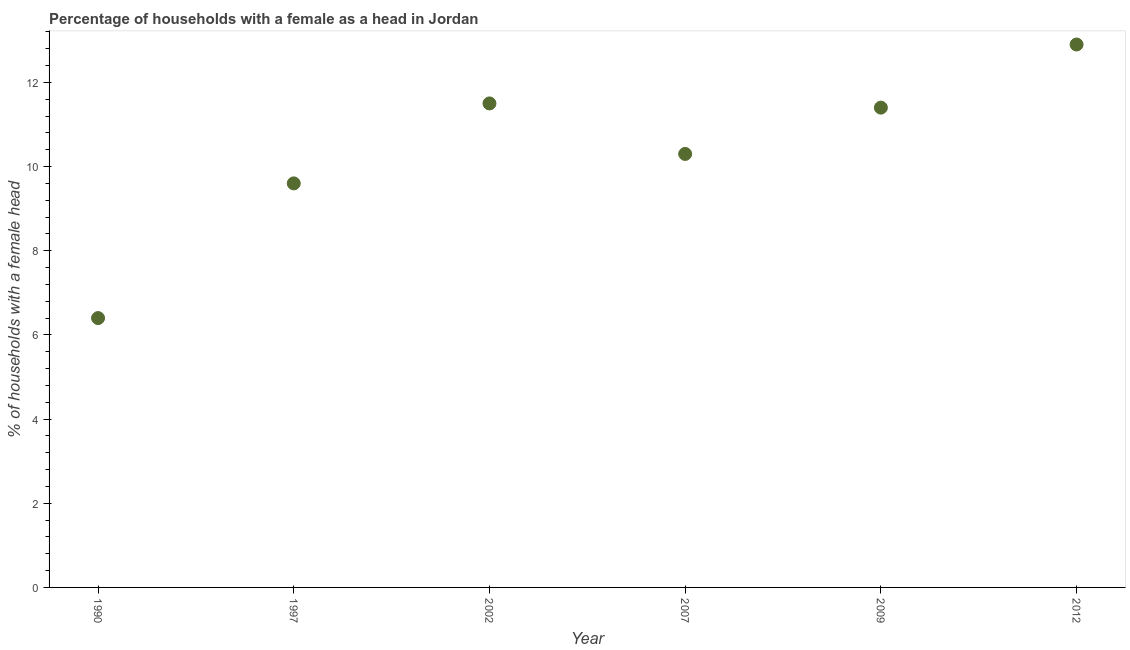What is the number of female supervised households in 2009?
Make the answer very short. 11.4. Across all years, what is the maximum number of female supervised households?
Ensure brevity in your answer.  12.9. What is the sum of the number of female supervised households?
Your answer should be compact. 62.1. What is the difference between the number of female supervised households in 1997 and 2009?
Offer a terse response. -1.8. What is the average number of female supervised households per year?
Provide a succinct answer. 10.35. What is the median number of female supervised households?
Make the answer very short. 10.85. In how many years, is the number of female supervised households greater than 7.2 %?
Give a very brief answer. 5. Do a majority of the years between 2007 and 1990 (inclusive) have number of female supervised households greater than 2 %?
Make the answer very short. Yes. What is the ratio of the number of female supervised households in 1997 to that in 2009?
Ensure brevity in your answer.  0.84. Is the difference between the number of female supervised households in 2002 and 2007 greater than the difference between any two years?
Provide a succinct answer. No. What is the difference between the highest and the second highest number of female supervised households?
Make the answer very short. 1.4. How many years are there in the graph?
Your answer should be compact. 6. Are the values on the major ticks of Y-axis written in scientific E-notation?
Your response must be concise. No. Does the graph contain any zero values?
Offer a very short reply. No. Does the graph contain grids?
Provide a short and direct response. No. What is the title of the graph?
Provide a succinct answer. Percentage of households with a female as a head in Jordan. What is the label or title of the X-axis?
Provide a short and direct response. Year. What is the label or title of the Y-axis?
Provide a succinct answer. % of households with a female head. What is the % of households with a female head in 1997?
Your answer should be compact. 9.6. What is the % of households with a female head in 2009?
Offer a terse response. 11.4. What is the difference between the % of households with a female head in 1990 and 2002?
Give a very brief answer. -5.1. What is the difference between the % of households with a female head in 1990 and 2009?
Ensure brevity in your answer.  -5. What is the difference between the % of households with a female head in 1990 and 2012?
Provide a succinct answer. -6.5. What is the difference between the % of households with a female head in 1997 and 2012?
Provide a succinct answer. -3.3. What is the ratio of the % of households with a female head in 1990 to that in 1997?
Give a very brief answer. 0.67. What is the ratio of the % of households with a female head in 1990 to that in 2002?
Give a very brief answer. 0.56. What is the ratio of the % of households with a female head in 1990 to that in 2007?
Keep it short and to the point. 0.62. What is the ratio of the % of households with a female head in 1990 to that in 2009?
Provide a short and direct response. 0.56. What is the ratio of the % of households with a female head in 1990 to that in 2012?
Give a very brief answer. 0.5. What is the ratio of the % of households with a female head in 1997 to that in 2002?
Provide a short and direct response. 0.83. What is the ratio of the % of households with a female head in 1997 to that in 2007?
Your response must be concise. 0.93. What is the ratio of the % of households with a female head in 1997 to that in 2009?
Your answer should be compact. 0.84. What is the ratio of the % of households with a female head in 1997 to that in 2012?
Make the answer very short. 0.74. What is the ratio of the % of households with a female head in 2002 to that in 2007?
Make the answer very short. 1.12. What is the ratio of the % of households with a female head in 2002 to that in 2009?
Your answer should be compact. 1.01. What is the ratio of the % of households with a female head in 2002 to that in 2012?
Keep it short and to the point. 0.89. What is the ratio of the % of households with a female head in 2007 to that in 2009?
Provide a short and direct response. 0.9. What is the ratio of the % of households with a female head in 2007 to that in 2012?
Keep it short and to the point. 0.8. What is the ratio of the % of households with a female head in 2009 to that in 2012?
Your answer should be very brief. 0.88. 